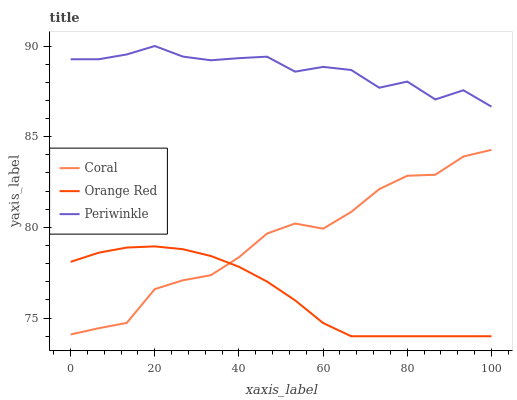Does Orange Red have the minimum area under the curve?
Answer yes or no. Yes. Does Periwinkle have the maximum area under the curve?
Answer yes or no. Yes. Does Periwinkle have the minimum area under the curve?
Answer yes or no. No. Does Orange Red have the maximum area under the curve?
Answer yes or no. No. Is Orange Red the smoothest?
Answer yes or no. Yes. Is Periwinkle the roughest?
Answer yes or no. Yes. Is Periwinkle the smoothest?
Answer yes or no. No. Is Orange Red the roughest?
Answer yes or no. No. Does Periwinkle have the lowest value?
Answer yes or no. No. Does Periwinkle have the highest value?
Answer yes or no. Yes. Does Orange Red have the highest value?
Answer yes or no. No. Is Coral less than Periwinkle?
Answer yes or no. Yes. Is Periwinkle greater than Coral?
Answer yes or no. Yes. Does Coral intersect Orange Red?
Answer yes or no. Yes. Is Coral less than Orange Red?
Answer yes or no. No. Is Coral greater than Orange Red?
Answer yes or no. No. Does Coral intersect Periwinkle?
Answer yes or no. No. 